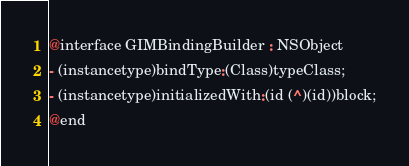<code> <loc_0><loc_0><loc_500><loc_500><_C_>
@interface GIMBindingBuilder : NSObject
- (instancetype)bindType:(Class)typeClass;
- (instancetype)initializedWith:(id (^)(id))block;
@end</code> 